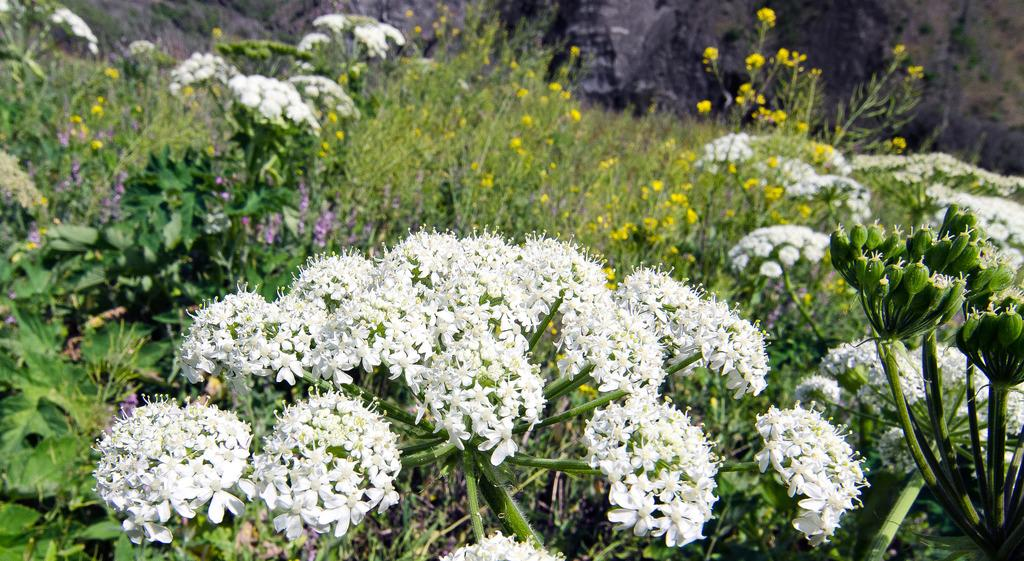What type of plants are in the image? There are flower plants in the image. What colors are the flowers? The flowers are white and yellow in color. What type of coil can be seen in the image? There is no coil present in the image; it features flower plants with white and yellow flowers. How many fish are visible in the image? There are no fish present in the image; it features flower plants with white and yellow flowers. 